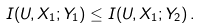<formula> <loc_0><loc_0><loc_500><loc_500>I ( U , X _ { 1 } ; Y _ { 1 } ) \leq I ( U , X _ { 1 } ; Y _ { 2 } ) \, .</formula> 